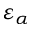<formula> <loc_0><loc_0><loc_500><loc_500>\varepsilon _ { \alpha }</formula> 